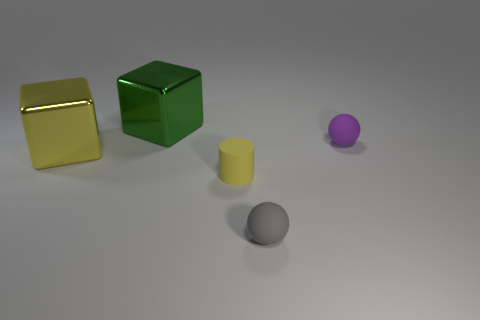Add 2 small cyan matte cylinders. How many objects exist? 7 Subtract all cubes. How many objects are left? 3 Subtract all large green objects. Subtract all tiny yellow objects. How many objects are left? 3 Add 2 shiny objects. How many shiny objects are left? 4 Add 3 yellow spheres. How many yellow spheres exist? 3 Subtract 1 gray spheres. How many objects are left? 4 